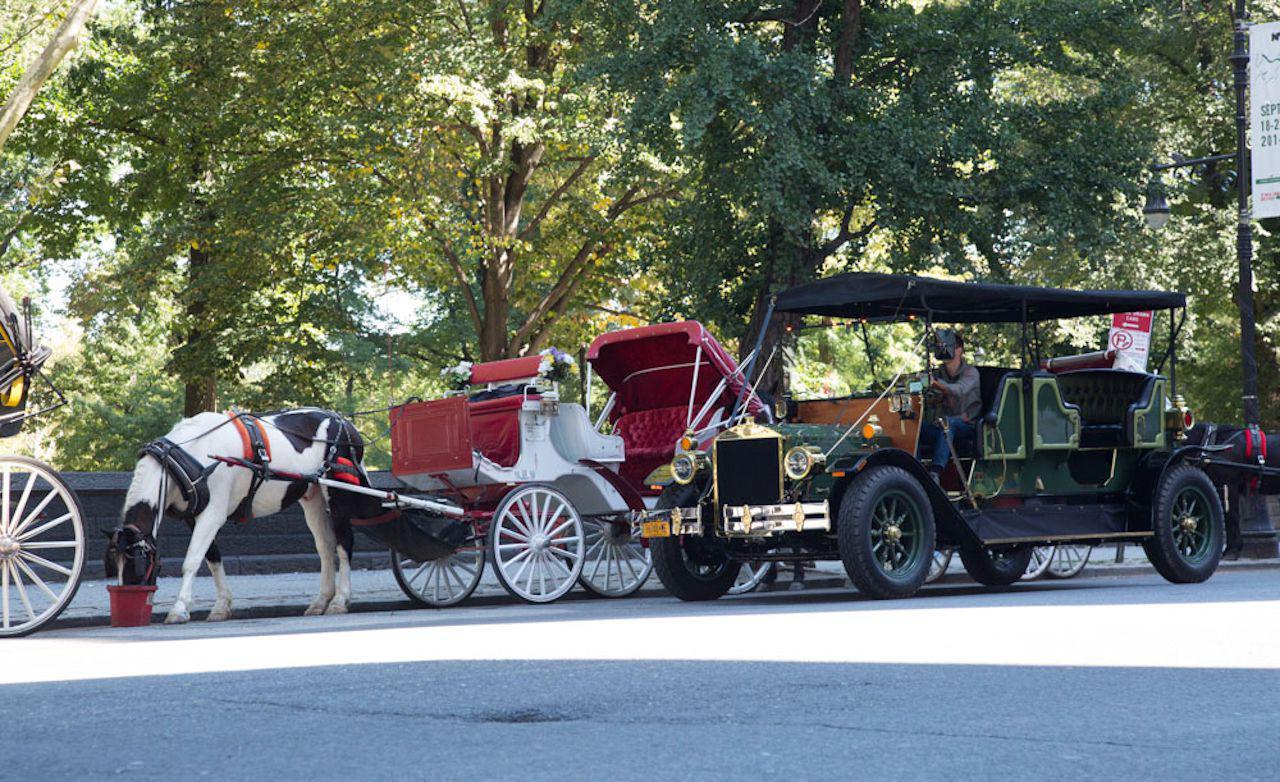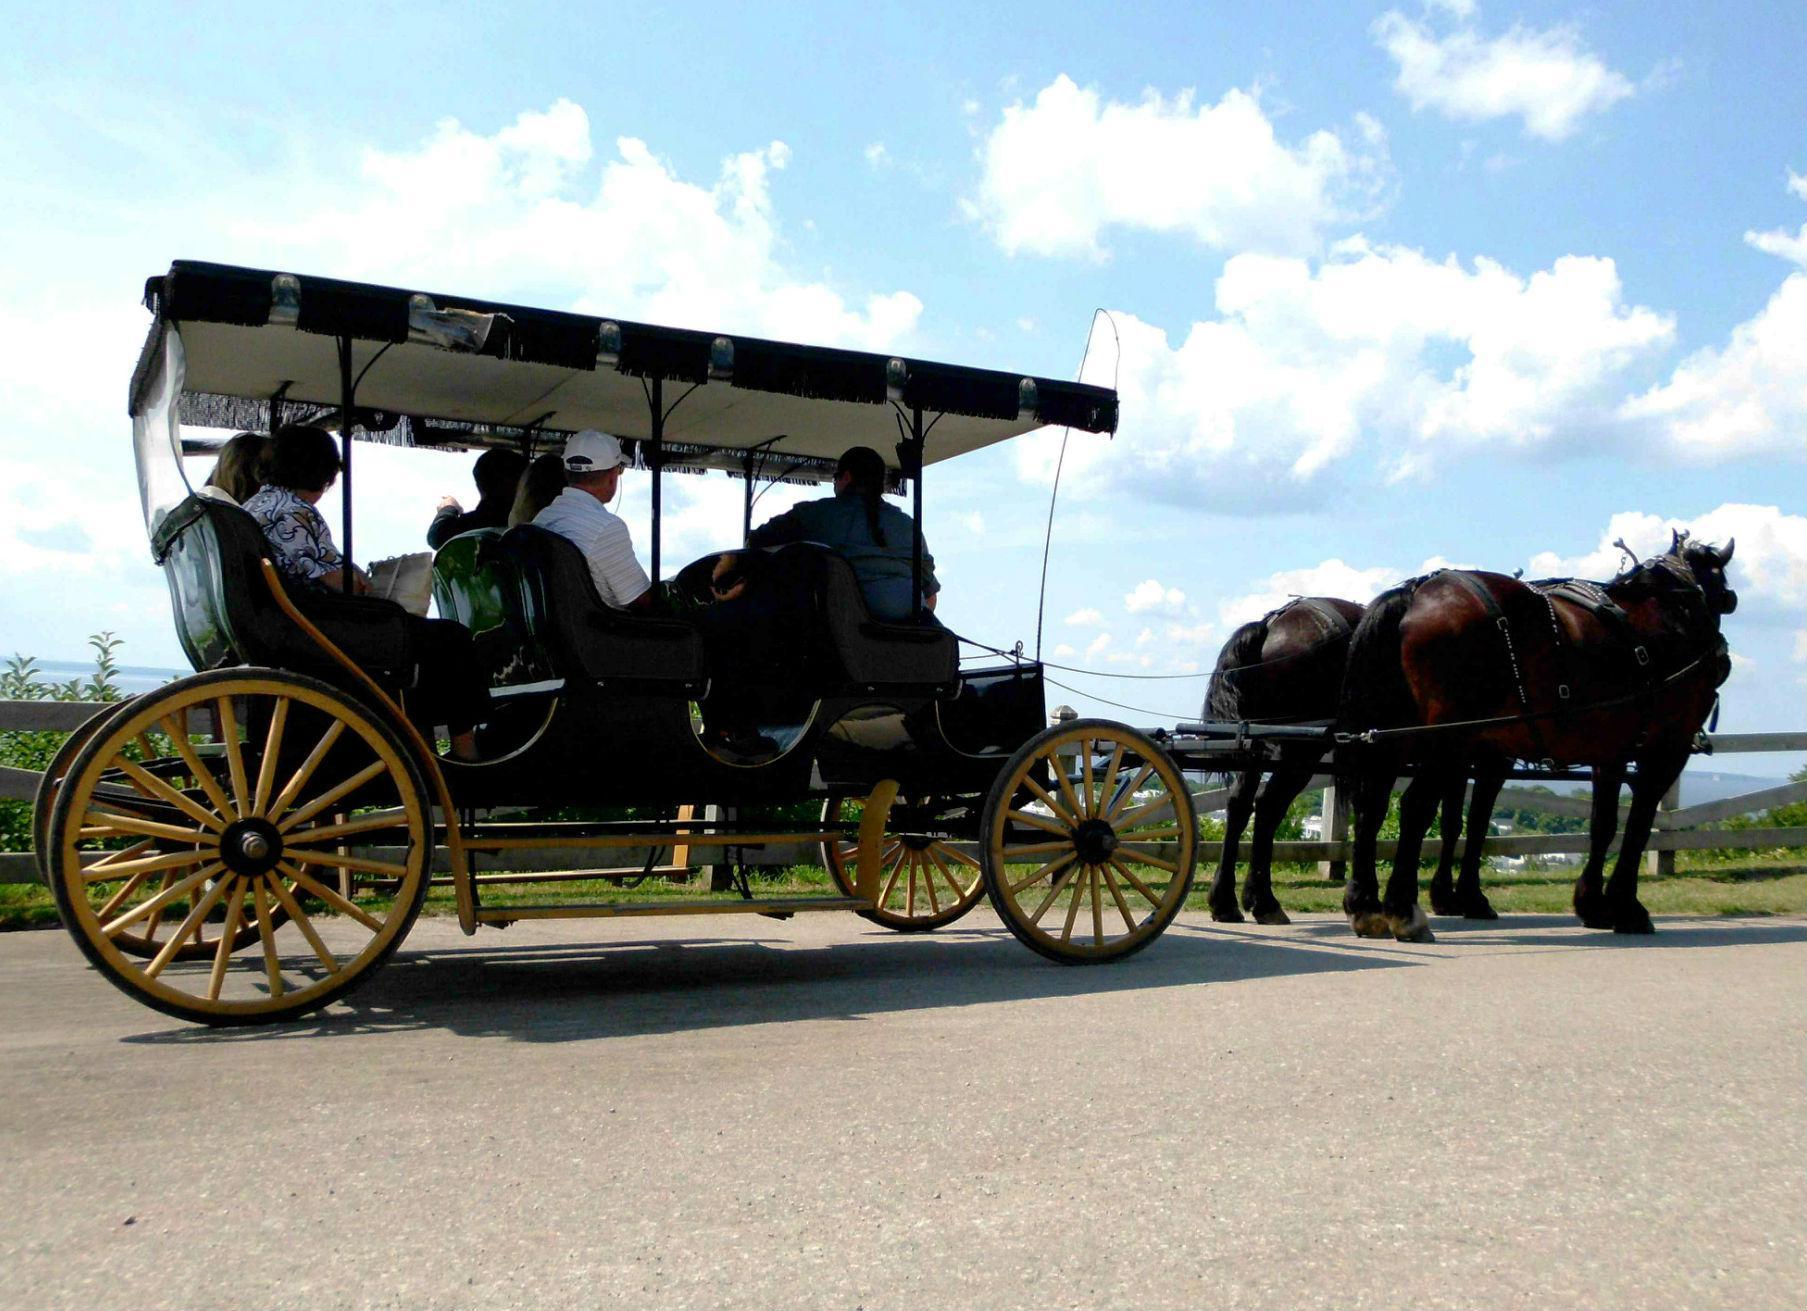The first image is the image on the left, the second image is the image on the right. Analyze the images presented: Is the assertion "The left image shows a carriage but no horses." valid? Answer yes or no. No. 